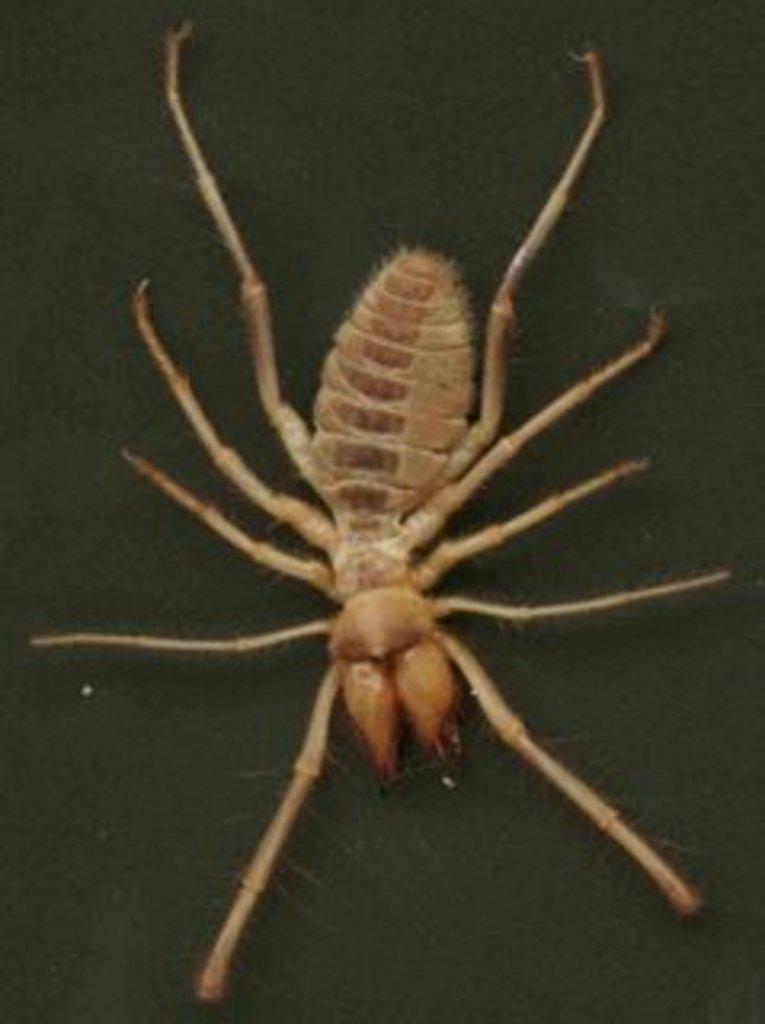In one or two sentences, can you explain what this image depicts? This picture shows a sun spider and we see a black color background. 